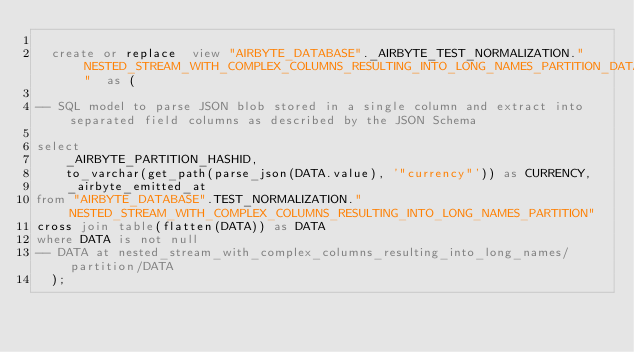<code> <loc_0><loc_0><loc_500><loc_500><_SQL_>
  create or replace  view "AIRBYTE_DATABASE"._AIRBYTE_TEST_NORMALIZATION."NESTED_STREAM_WITH_COMPLEX_COLUMNS_RESULTING_INTO_LONG_NAMES_PARTITION_DATA_AB1"  as (
    
-- SQL model to parse JSON blob stored in a single column and extract into separated field columns as described by the JSON Schema

select
    _AIRBYTE_PARTITION_HASHID,
    to_varchar(get_path(parse_json(DATA.value), '"currency"')) as CURRENCY,
    _airbyte_emitted_at
from "AIRBYTE_DATABASE".TEST_NORMALIZATION."NESTED_STREAM_WITH_COMPLEX_COLUMNS_RESULTING_INTO_LONG_NAMES_PARTITION"
cross join table(flatten(DATA)) as DATA
where DATA is not null
-- DATA at nested_stream_with_complex_columns_resulting_into_long_names/partition/DATA
  );
</code> 